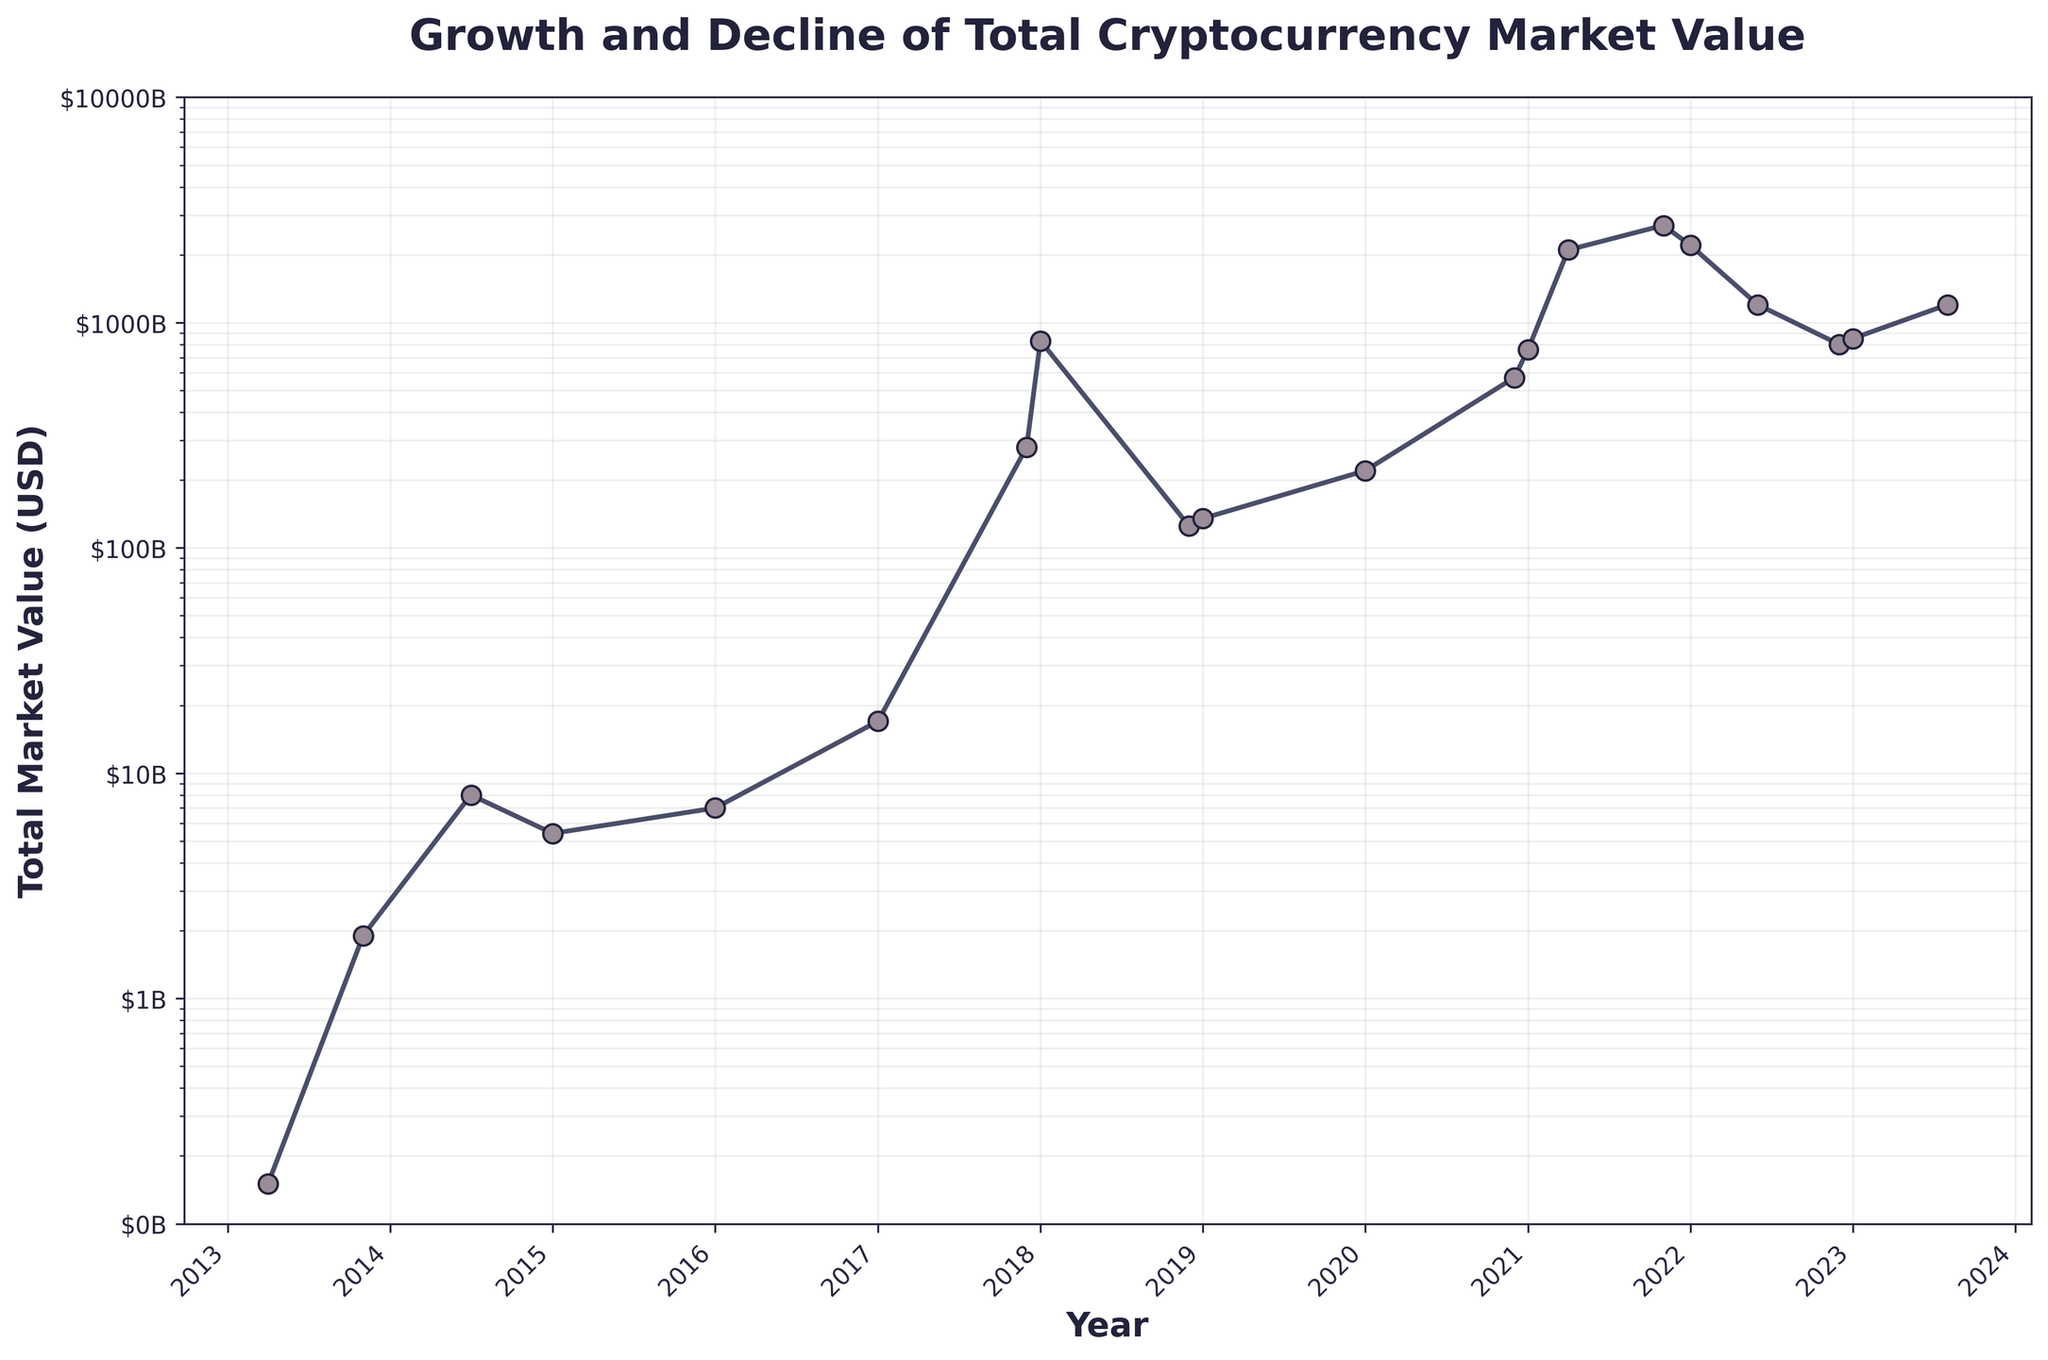what is the title of the figure? The title of the figure is written at the top of the plot and provides a summary of what the plot is about.
Answer: Growth and Decline of Total Cryptocurrency Market Value How many major peaks does the cryptocurrency market value exhibit from the inception to the present? To answer, observe the plot for points where the market reaches high values before declining again.
Answer: Three During what period did the cryptocurrency market value first exceed $1 trillion? Look at the plot for the first point where the y-value (market value) surpasses the $1 trillion mark. The x-value (date) at that point indicates the period.
Answer: 2021 By how much did the cryptocurrency market value change between January 2022 and June 2022? Find the y-values for January 2022 and June 2022. Subtract the market value at June 2022 from January 2022 to find the difference.
Answer: $1 trillion When was the highest market value recorded, and what was the value? Look for the highest point (peak) on the plot, note the date (x-axis) and the market value (y-axis) at that point.
Answer: November 2021, $2.7 trillion Compare the market value in January 2018 and December 2018. Which was higher, and by how much? Identify the points for January 2018 and December 2018. Calculate the difference by subtracting the December 2018 value from January 2018 value.
Answer: January 2018 was higher by $705 billion What’s the overall trend in the total cryptocurrency market value from 2013 to 2023? Observe the overall direction of the line from the left-most point to the right-most point.
Answer: Upward trend What is the average market value for the year 2020? Find the average of the y-values (market values) for all the dates within the year 2020 listed on the plot.
Answer: $395 billion Which year had the steepest increase in market value, and what was the approximate value increase? Identify the year with the steepest slope (sharp increase) by looking at the steepest section of the line plot. Calculate the difference in the market value from the beginning to the end of that year.
Answer: 2021, $2 trillion 